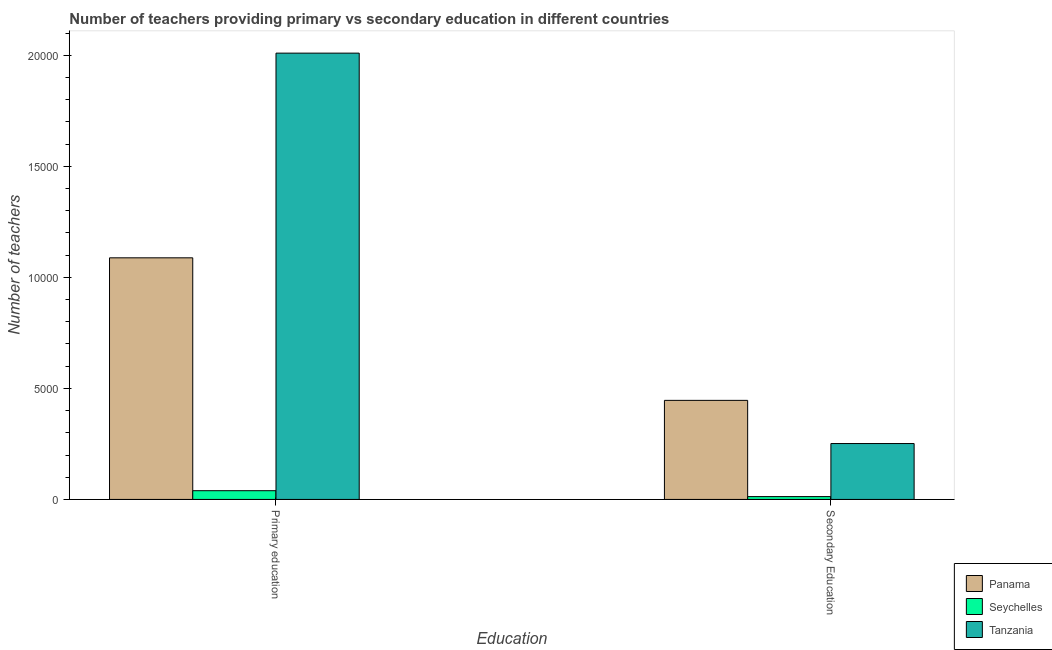How many different coloured bars are there?
Your answer should be very brief. 3. How many groups of bars are there?
Your answer should be compact. 2. Are the number of bars per tick equal to the number of legend labels?
Ensure brevity in your answer.  Yes. How many bars are there on the 2nd tick from the left?
Ensure brevity in your answer.  3. What is the number of secondary teachers in Tanzania?
Your response must be concise. 2516. Across all countries, what is the maximum number of primary teachers?
Offer a terse response. 2.01e+04. Across all countries, what is the minimum number of primary teachers?
Give a very brief answer. 393. In which country was the number of primary teachers maximum?
Ensure brevity in your answer.  Tanzania. In which country was the number of secondary teachers minimum?
Offer a terse response. Seychelles. What is the total number of secondary teachers in the graph?
Make the answer very short. 7103. What is the difference between the number of secondary teachers in Panama and that in Tanzania?
Your response must be concise. 1944. What is the difference between the number of primary teachers in Seychelles and the number of secondary teachers in Panama?
Offer a very short reply. -4067. What is the average number of secondary teachers per country?
Your answer should be compact. 2367.67. What is the difference between the number of secondary teachers and number of primary teachers in Panama?
Your answer should be very brief. -6418. What is the ratio of the number of secondary teachers in Tanzania to that in Seychelles?
Your answer should be very brief. 19.81. Is the number of secondary teachers in Tanzania less than that in Panama?
Ensure brevity in your answer.  Yes. What does the 2nd bar from the left in Secondary Education represents?
Offer a very short reply. Seychelles. What does the 2nd bar from the right in Secondary Education represents?
Offer a very short reply. Seychelles. Are all the bars in the graph horizontal?
Your answer should be compact. No. Does the graph contain any zero values?
Make the answer very short. No. Does the graph contain grids?
Make the answer very short. No. Where does the legend appear in the graph?
Offer a terse response. Bottom right. How many legend labels are there?
Give a very brief answer. 3. What is the title of the graph?
Give a very brief answer. Number of teachers providing primary vs secondary education in different countries. What is the label or title of the X-axis?
Your response must be concise. Education. What is the label or title of the Y-axis?
Offer a very short reply. Number of teachers. What is the Number of teachers in Panama in Primary education?
Provide a succinct answer. 1.09e+04. What is the Number of teachers of Seychelles in Primary education?
Your answer should be very brief. 393. What is the Number of teachers of Tanzania in Primary education?
Give a very brief answer. 2.01e+04. What is the Number of teachers in Panama in Secondary Education?
Offer a very short reply. 4460. What is the Number of teachers of Seychelles in Secondary Education?
Provide a succinct answer. 127. What is the Number of teachers of Tanzania in Secondary Education?
Offer a very short reply. 2516. Across all Education, what is the maximum Number of teachers of Panama?
Your answer should be very brief. 1.09e+04. Across all Education, what is the maximum Number of teachers of Seychelles?
Your answer should be compact. 393. Across all Education, what is the maximum Number of teachers in Tanzania?
Your answer should be compact. 2.01e+04. Across all Education, what is the minimum Number of teachers of Panama?
Keep it short and to the point. 4460. Across all Education, what is the minimum Number of teachers in Seychelles?
Keep it short and to the point. 127. Across all Education, what is the minimum Number of teachers in Tanzania?
Provide a succinct answer. 2516. What is the total Number of teachers in Panama in the graph?
Ensure brevity in your answer.  1.53e+04. What is the total Number of teachers of Seychelles in the graph?
Keep it short and to the point. 520. What is the total Number of teachers of Tanzania in the graph?
Provide a short and direct response. 2.26e+04. What is the difference between the Number of teachers of Panama in Primary education and that in Secondary Education?
Offer a very short reply. 6418. What is the difference between the Number of teachers of Seychelles in Primary education and that in Secondary Education?
Give a very brief answer. 266. What is the difference between the Number of teachers of Tanzania in Primary education and that in Secondary Education?
Ensure brevity in your answer.  1.76e+04. What is the difference between the Number of teachers of Panama in Primary education and the Number of teachers of Seychelles in Secondary Education?
Offer a terse response. 1.08e+04. What is the difference between the Number of teachers in Panama in Primary education and the Number of teachers in Tanzania in Secondary Education?
Offer a very short reply. 8362. What is the difference between the Number of teachers of Seychelles in Primary education and the Number of teachers of Tanzania in Secondary Education?
Give a very brief answer. -2123. What is the average Number of teachers in Panama per Education?
Offer a very short reply. 7669. What is the average Number of teachers of Seychelles per Education?
Give a very brief answer. 260. What is the average Number of teachers in Tanzania per Education?
Keep it short and to the point. 1.13e+04. What is the difference between the Number of teachers of Panama and Number of teachers of Seychelles in Primary education?
Make the answer very short. 1.05e+04. What is the difference between the Number of teachers of Panama and Number of teachers of Tanzania in Primary education?
Ensure brevity in your answer.  -9216. What is the difference between the Number of teachers of Seychelles and Number of teachers of Tanzania in Primary education?
Make the answer very short. -1.97e+04. What is the difference between the Number of teachers of Panama and Number of teachers of Seychelles in Secondary Education?
Provide a short and direct response. 4333. What is the difference between the Number of teachers of Panama and Number of teachers of Tanzania in Secondary Education?
Provide a short and direct response. 1944. What is the difference between the Number of teachers of Seychelles and Number of teachers of Tanzania in Secondary Education?
Offer a very short reply. -2389. What is the ratio of the Number of teachers in Panama in Primary education to that in Secondary Education?
Offer a very short reply. 2.44. What is the ratio of the Number of teachers in Seychelles in Primary education to that in Secondary Education?
Provide a short and direct response. 3.09. What is the ratio of the Number of teachers of Tanzania in Primary education to that in Secondary Education?
Give a very brief answer. 7.99. What is the difference between the highest and the second highest Number of teachers of Panama?
Provide a short and direct response. 6418. What is the difference between the highest and the second highest Number of teachers in Seychelles?
Give a very brief answer. 266. What is the difference between the highest and the second highest Number of teachers in Tanzania?
Make the answer very short. 1.76e+04. What is the difference between the highest and the lowest Number of teachers in Panama?
Provide a succinct answer. 6418. What is the difference between the highest and the lowest Number of teachers of Seychelles?
Keep it short and to the point. 266. What is the difference between the highest and the lowest Number of teachers in Tanzania?
Your answer should be compact. 1.76e+04. 